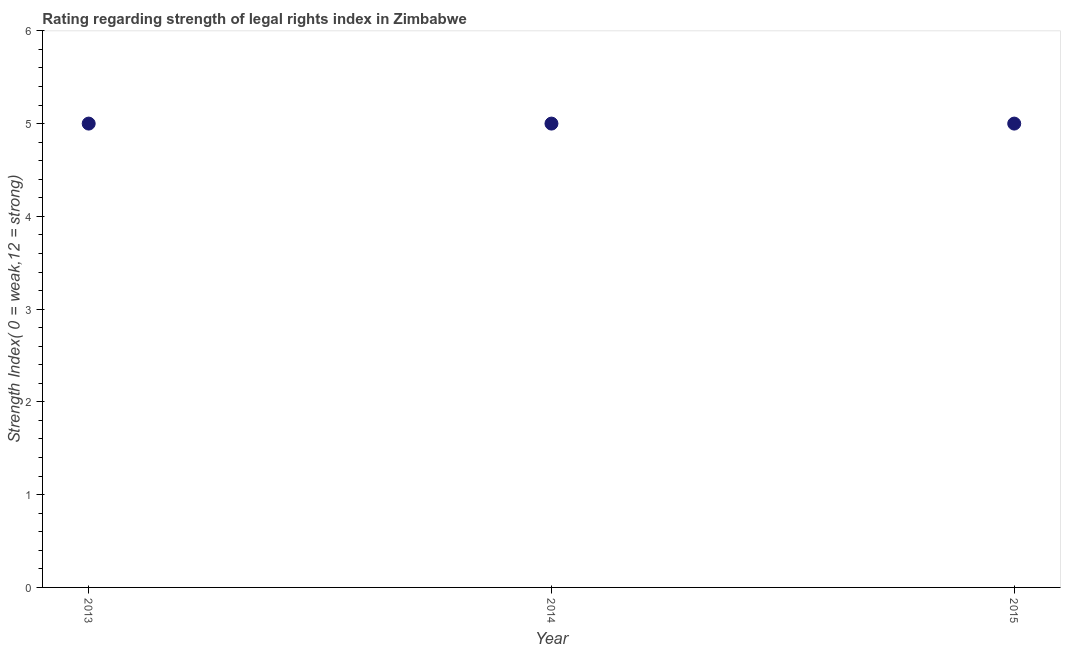What is the strength of legal rights index in 2014?
Offer a terse response. 5. Across all years, what is the maximum strength of legal rights index?
Provide a short and direct response. 5. Across all years, what is the minimum strength of legal rights index?
Ensure brevity in your answer.  5. What is the sum of the strength of legal rights index?
Offer a terse response. 15. What is the ratio of the strength of legal rights index in 2013 to that in 2014?
Ensure brevity in your answer.  1. Is the difference between the strength of legal rights index in 2013 and 2014 greater than the difference between any two years?
Your answer should be very brief. Yes. What is the difference between the highest and the lowest strength of legal rights index?
Your answer should be very brief. 0. In how many years, is the strength of legal rights index greater than the average strength of legal rights index taken over all years?
Your answer should be compact. 0. How many years are there in the graph?
Make the answer very short. 3. What is the difference between two consecutive major ticks on the Y-axis?
Offer a very short reply. 1. Are the values on the major ticks of Y-axis written in scientific E-notation?
Keep it short and to the point. No. Does the graph contain any zero values?
Your response must be concise. No. Does the graph contain grids?
Make the answer very short. No. What is the title of the graph?
Ensure brevity in your answer.  Rating regarding strength of legal rights index in Zimbabwe. What is the label or title of the Y-axis?
Give a very brief answer. Strength Index( 0 = weak,12 = strong). What is the Strength Index( 0 = weak,12 = strong) in 2013?
Provide a short and direct response. 5. What is the Strength Index( 0 = weak,12 = strong) in 2014?
Your answer should be very brief. 5. What is the Strength Index( 0 = weak,12 = strong) in 2015?
Ensure brevity in your answer.  5. What is the difference between the Strength Index( 0 = weak,12 = strong) in 2013 and 2014?
Keep it short and to the point. 0. What is the difference between the Strength Index( 0 = weak,12 = strong) in 2014 and 2015?
Your response must be concise. 0. 